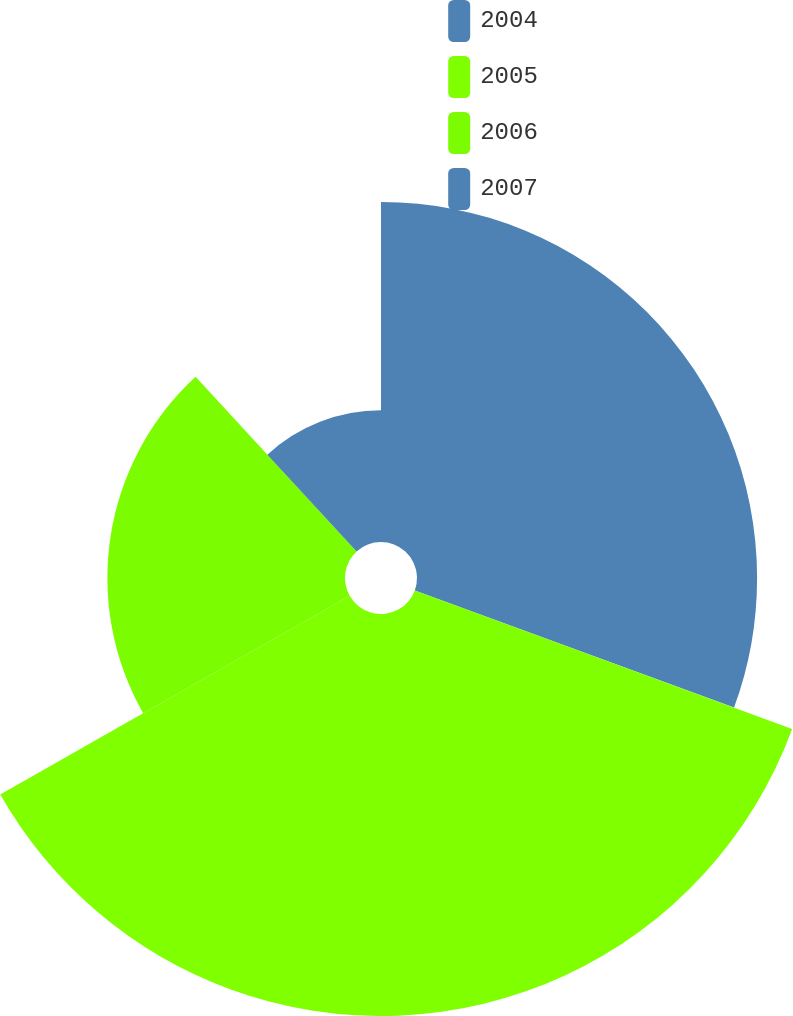<chart> <loc_0><loc_0><loc_500><loc_500><pie_chart><fcel>2004<fcel>2005<fcel>2006<fcel>2007<nl><fcel>30.6%<fcel>36.17%<fcel>21.38%<fcel>11.85%<nl></chart> 